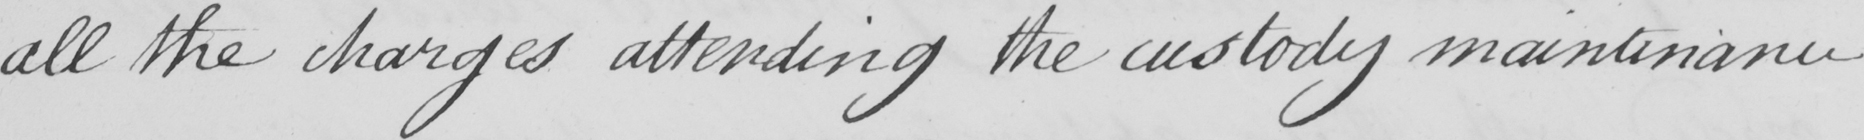Can you tell me what this handwritten text says? all the charges attending the custody maintenance 